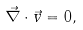<formula> <loc_0><loc_0><loc_500><loc_500>\vec { \nabla } \cdot \vec { v } = 0 ,</formula> 